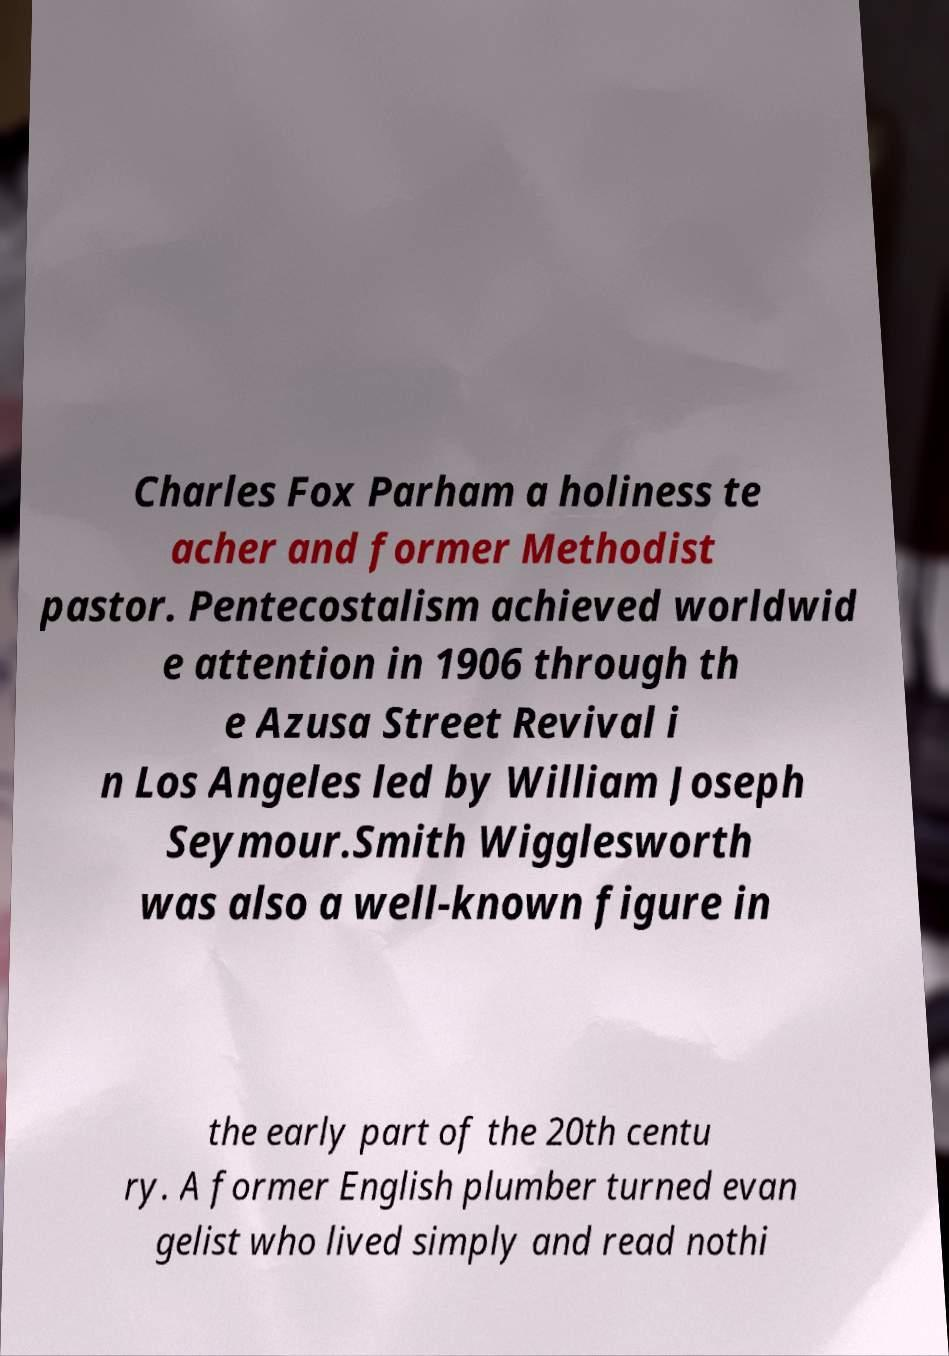For documentation purposes, I need the text within this image transcribed. Could you provide that? Charles Fox Parham a holiness te acher and former Methodist pastor. Pentecostalism achieved worldwid e attention in 1906 through th e Azusa Street Revival i n Los Angeles led by William Joseph Seymour.Smith Wigglesworth was also a well-known figure in the early part of the 20th centu ry. A former English plumber turned evan gelist who lived simply and read nothi 